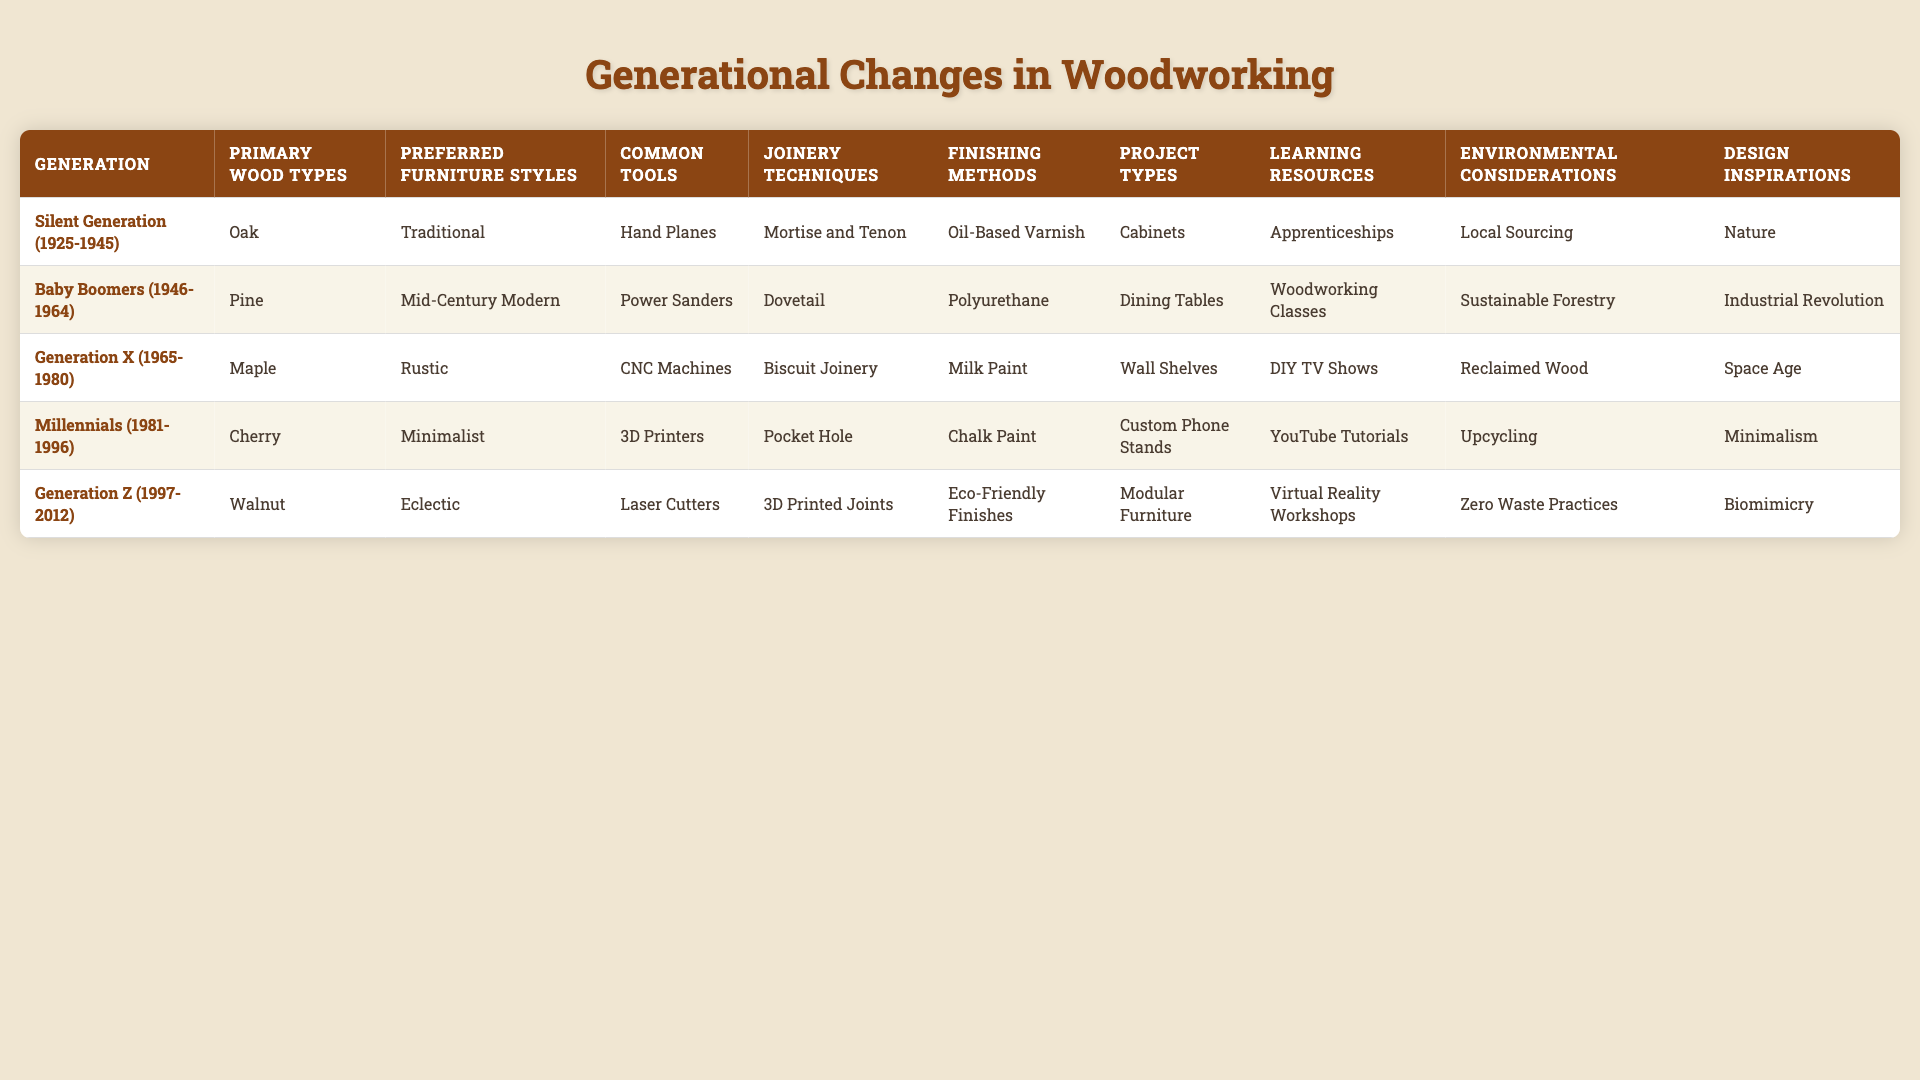What is the primary wood type preferred by Millennials? The table indicates that Millennials primarily prefer Cherry as their wood type.
Answer: Cherry Which generation preferred the Dovetail joinery technique? According to the table, the Silent Generation preferred the Dovetail joinery technique.
Answer: Silent Generation Does Generation Z favor eco-friendly finishes? Yes, the table shows that Generation Z prefers Eco-Friendly Finishes.
Answer: Yes What are the common tools used by Baby Boomers? The table lists Power Sanders as the common tools used by Baby Boomers.
Answer: Power Sanders How many different project types are listed for Generation X? There is one project type listed for Generation X, which is Wall Shelves.
Answer: 1 What is the primary wood type used for rustic furniture by the Silent Generation? The Silent Generation primarily uses Oak as their wood type, which is often associated with rustic furniture.
Answer: Oak Which joinery technique is most commonly found in the projects of Generation Z? The table shows that Generation Z uses 3D Printed Joints as their joinery technique.
Answer: 3D Printed Joints Is there a generation that focuses on Upcycling in their woodworking practices? Yes, Generation Z focuses on Upcycling based on the environmental considerations shown in the table.
Answer: Yes What design inspiration is associated with the Millennials? The table specifies that Millennials are inspired by Minimalism in their designs.
Answer: Minimalism Compare the preferred furniture styles of the Silent Generation and Baby Boomers. Which one has a more traditional style? The Silent Generation prefers Traditional furniture styles, while Baby Boomers prefer Mid-Century Modern, making Traditional the more traditional style.
Answer: Silent Generation Which generation uses Virtual Reality Workshops as their primary learning resource? The table indicates that Generation Z uses Virtual Reality Workshops as their primary learning resource.
Answer: Generation Z What is the difference between the common tools used by the Silent Generation and Millennials? The Silent Generation uses Hand Planes, while Millennials use 3D Printers, making the difference in technology and usage significant.
Answer: Hand Planes vs 3D Printers 